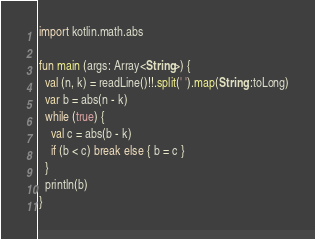Convert code to text. <code><loc_0><loc_0><loc_500><loc_500><_Kotlin_>import kotlin.math.abs

fun main (args: Array<String>) {
  val (n, k) = readLine()!!.split(' ').map(String::toLong)
  var b = abs(n - k)
  while (true) {
    val c = abs(b - k)
    if (b < c) break else { b = c }
  }
  println(b)
}</code> 